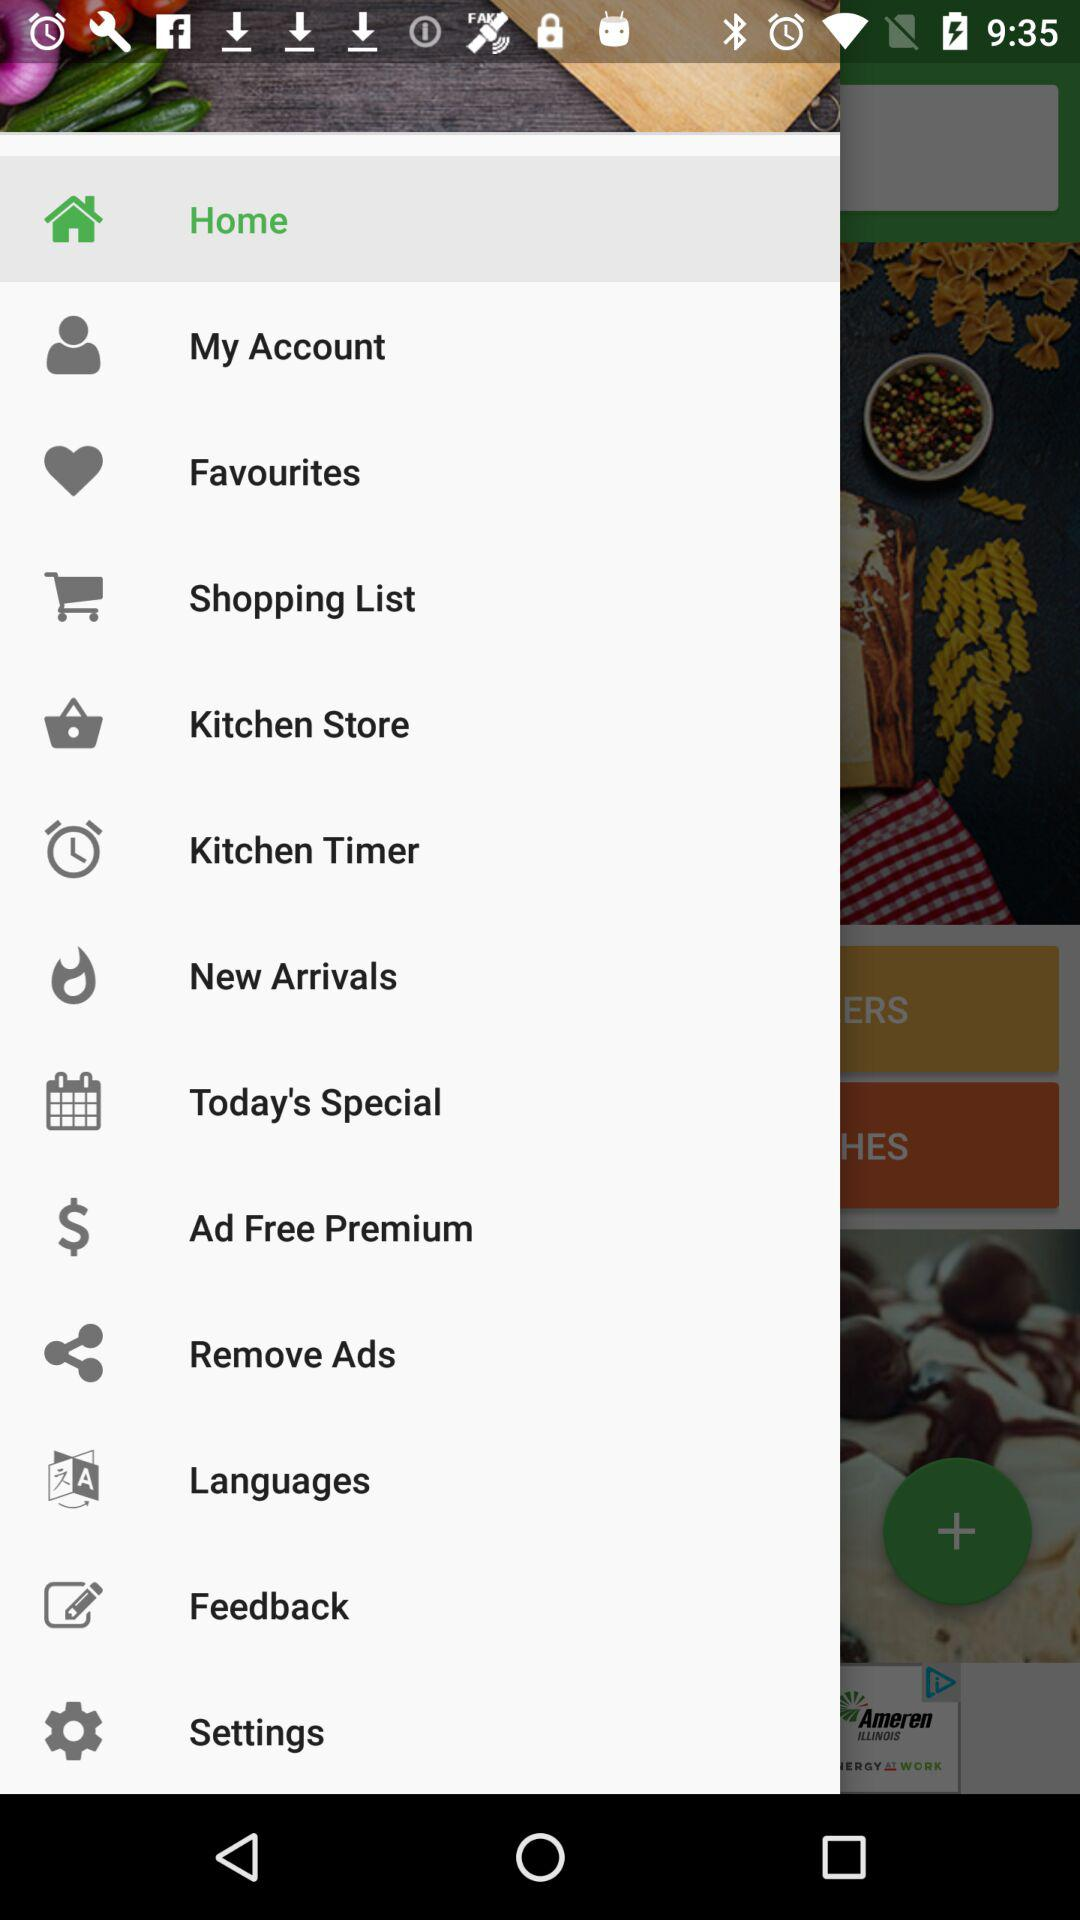Which option has been selected? The option that has been selected is "Home". 